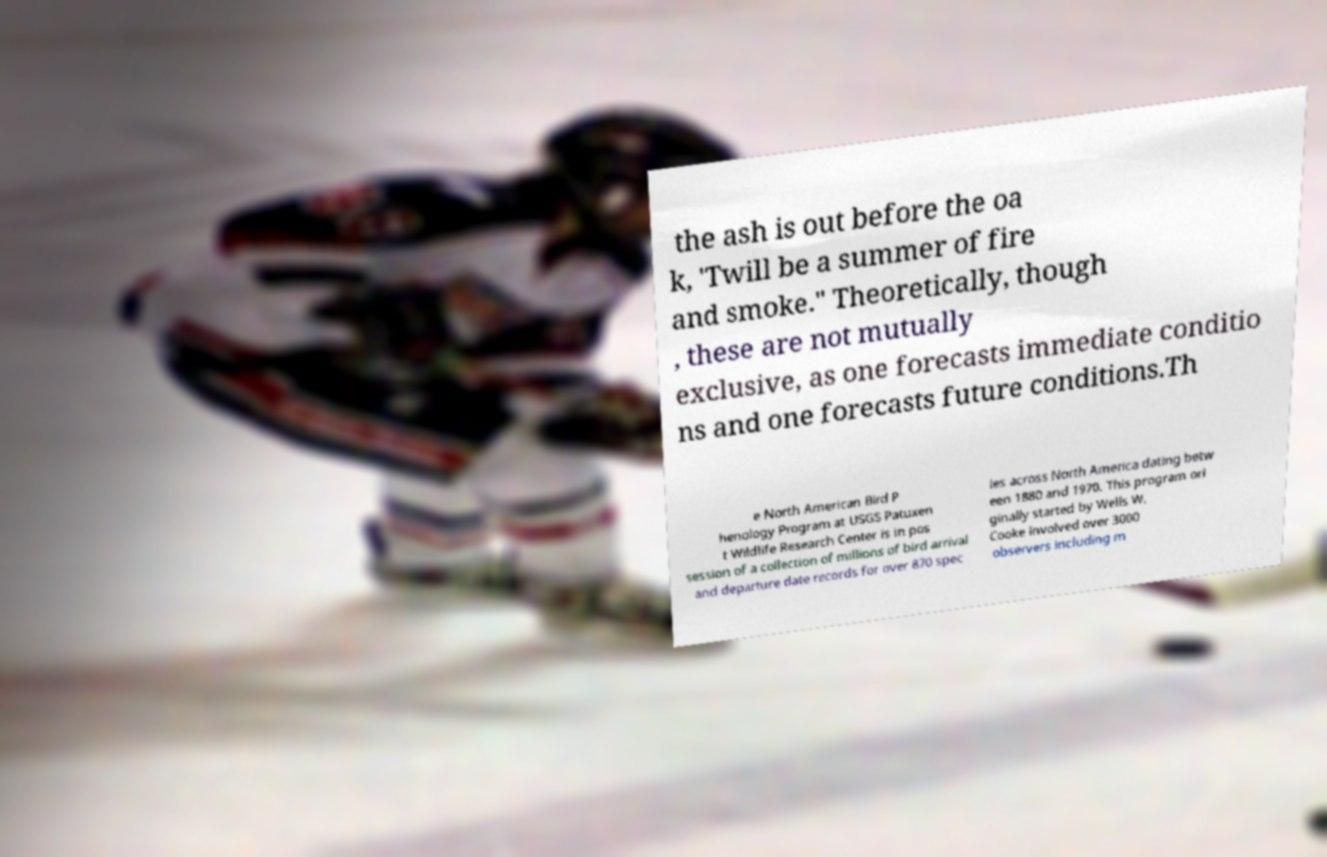Can you read and provide the text displayed in the image?This photo seems to have some interesting text. Can you extract and type it out for me? the ash is out before the oa k, 'Twill be a summer of fire and smoke." Theoretically, though , these are not mutually exclusive, as one forecasts immediate conditio ns and one forecasts future conditions.Th e North American Bird P henology Program at USGS Patuxen t Wildlife Research Center is in pos session of a collection of millions of bird arrival and departure date records for over 870 spec ies across North America dating betw een 1880 and 1970. This program ori ginally started by Wells W. Cooke involved over 3000 observers including m 